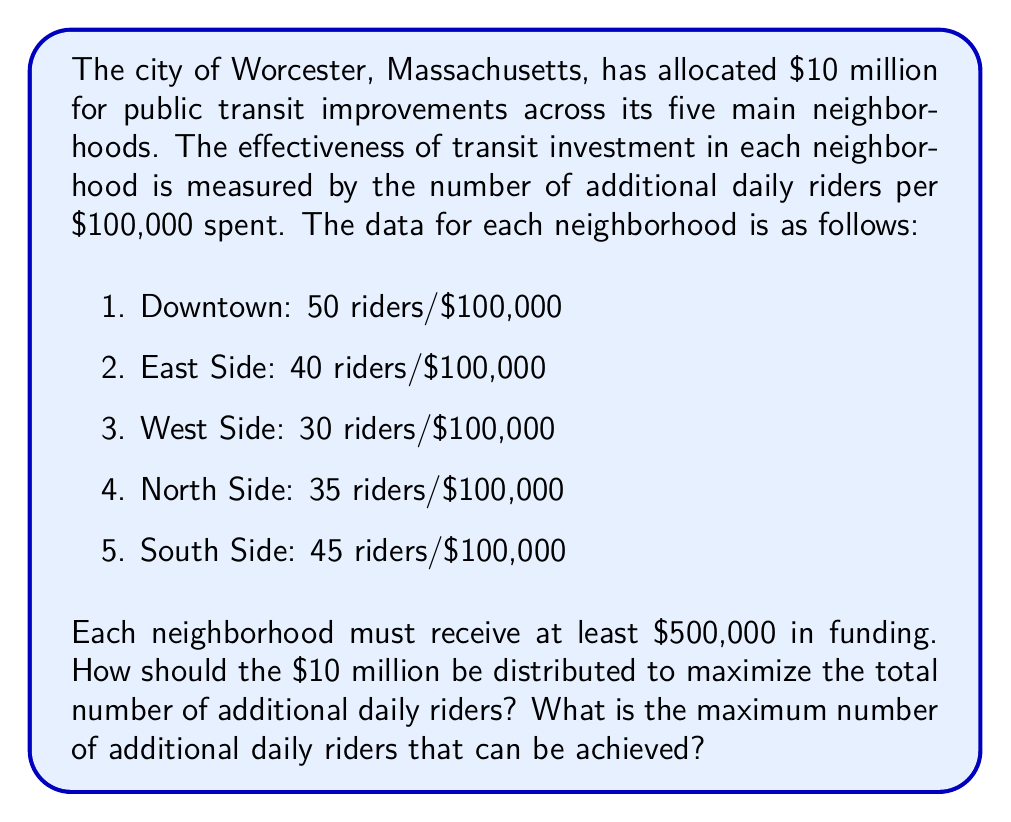Solve this math problem. To solve this problem, we'll use the simplex method for linear programming. Let's define our variables and set up the problem:

Let $x_1, x_2, x_3, x_4,$ and $x_5$ represent the funding (in hundreds of thousands of dollars) for Downtown, East Side, West Side, North Side, and South Side, respectively.

Our objective function to maximize is:
$$50x_1 + 40x_2 + 30x_3 + 35x_4 + 45x_5$$

Subject to the constraints:
$$x_1 + x_2 + x_3 + x_4 + x_5 \leq 100$$ (total budget constraint)
$$x_1, x_2, x_3, x_4, x_5 \geq 5$$ (minimum funding constraint)

To solve this using the simplex method, we need to add slack variables and convert the problem to standard form:

Maximize:
$$50x_1 + 40x_2 + 30x_3 + 35x_4 + 45x_5 + 0s_1 + 0s_2 + 0s_3 + 0s_4 + 0s_5 + 0s_6$$

Subject to:
$$x_1 + x_2 + x_3 + x_4 + x_5 + s_1 = 100$$
$$x_1 - s_2 = 5$$
$$x_2 - s_3 = 5$$
$$x_3 - s_4 = 5$$
$$x_4 - s_5 = 5$$
$$x_5 - s_6 = 5$$

All variables $\geq 0$

Solving this using the simplex method (which involves multiple iterations of pivoting), we arrive at the optimal solution:

$$x_1 = 75, x_2 = 5, x_3 = 5, x_4 = 5, x_5 = 10$$

This means:
- Downtown: $7.5 million
- East Side: $0.5 million
- West Side: $0.5 million
- North Side: $0.5 million
- South Side: $1 million

The maximum number of additional daily riders can be calculated by plugging these values into our objective function:

$50(75) + 40(5) + 30(5) + 35(5) + 45(10) = 4,325$
Answer: The optimal distribution of the $10 million budget is:
Downtown: $7.5 million
East Side: $0.5 million
West Side: $0.5 million
North Side: $0.5 million
South Side: $1 million

This distribution will result in a maximum of 4,325 additional daily riders. 